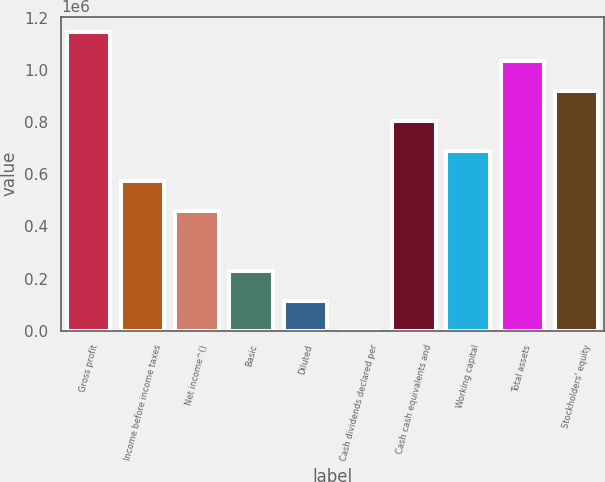<chart> <loc_0><loc_0><loc_500><loc_500><bar_chart><fcel>Gross profit<fcel>Income before income taxes<fcel>Net income^()<fcel>Basic<fcel>Diluted<fcel>Cash dividends declared per<fcel>Cash cash equivalents and<fcel>Working capital<fcel>Total assets<fcel>Stockholders' equity<nl><fcel>1.14827e+06<fcel>574135<fcel>459308<fcel>229654<fcel>114827<fcel>0.05<fcel>803788<fcel>688961<fcel>1.03344e+06<fcel>918615<nl></chart> 